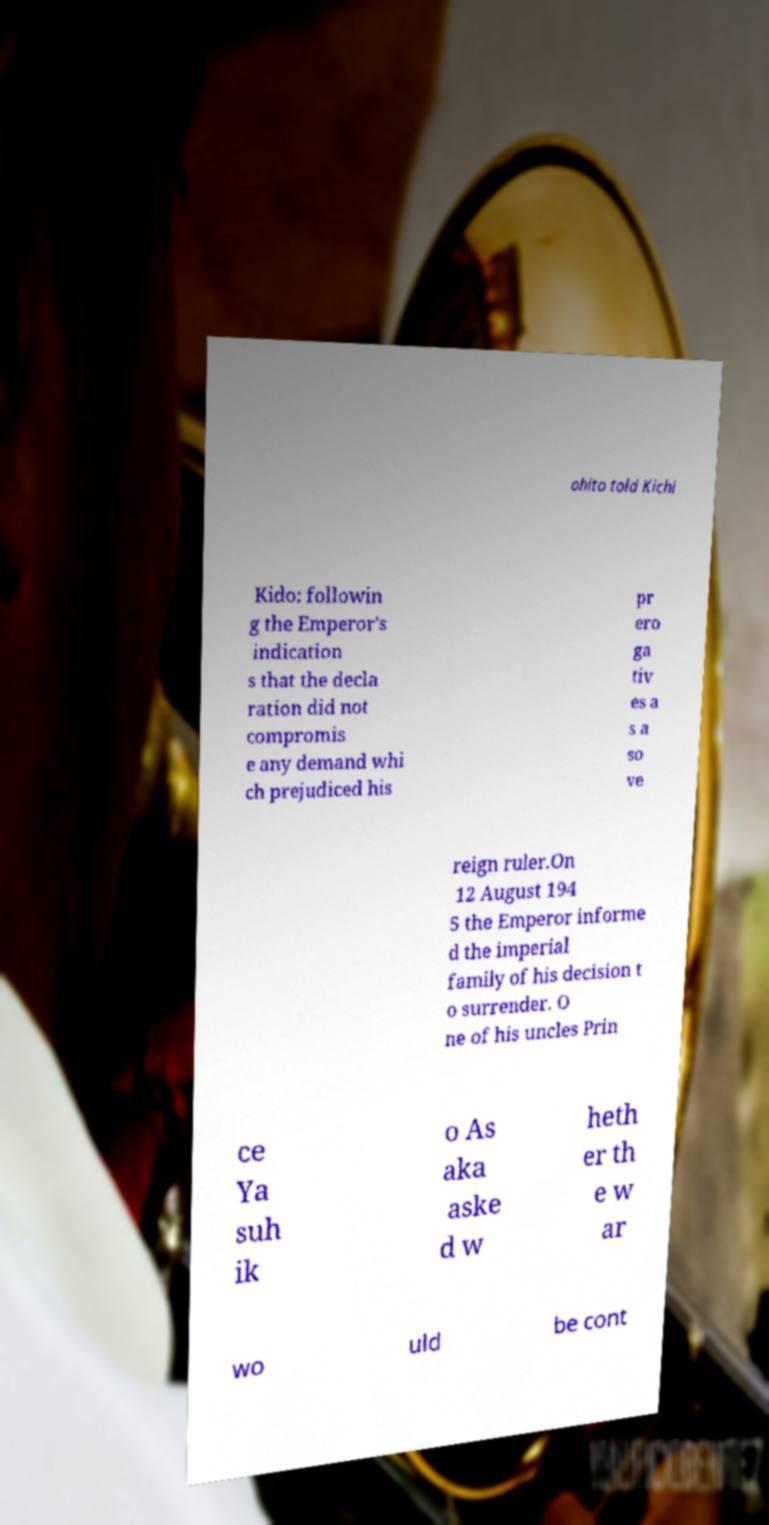Could you assist in decoding the text presented in this image and type it out clearly? ohito told Kichi Kido: followin g the Emperor's indication s that the decla ration did not compromis e any demand whi ch prejudiced his pr ero ga tiv es a s a so ve reign ruler.On 12 August 194 5 the Emperor informe d the imperial family of his decision t o surrender. O ne of his uncles Prin ce Ya suh ik o As aka aske d w heth er th e w ar wo uld be cont 